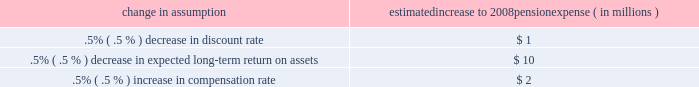Recent accounting pronouncements see note 1 accounting policies in the notes to consolidated financial statements in item 8 of this report for additional information on the following recent accounting pronouncements that are relevant to our business , including a description of each new pronouncement , the required date of adoption , our planned date of adoption , and the expected impact on our consolidated financial statements .
All of the following pronouncements were issued by the fasb unless otherwise noted .
The following were issued in 2007 : 2022 sfas 141 ( r ) , 201cbusiness combinations 201d 2022 sfas 160 , 201caccounting and reporting of noncontrolling interests in consolidated financial statements , an amendment of arb no .
51 201d 2022 in november 2007 , the sec issued staff accounting bulletin no .
109 , 2022 in june 2007 , the aicpa issued statement of position 07-1 , 201cclarification of the scope of the audit and accounting guide 201cinvestment companies 201d and accounting by parent companies and equity method investors for investments in investment companies . 201d the fasb issued a final fsp in february 2008 which indefinitely delays the effective date of aicpa sop 07-1 .
2022 fasb staff position no .
( 201cfsp 201d ) fin 46 ( r ) 7 , 201capplication of fasb interpretation no .
46 ( r ) to investment companies 201d 2022 fsp fin 48-1 , 201cdefinition of settlement in fasb interpretation ( 201cfin 201d ) no .
48 201d 2022 sfas 159 , 201cthe fair value option for financial assets and financial liabilities 2013 including an amendment of fasb statement no .
115 201d the following were issued during 2006 : 2022 sfas 158 , 201cemployers 2019 accounting for defined benefit pension and other postretirement benefit plans 2013 an amendment of fasb statements no .
87 , 88 , 106 and 132 ( r ) 201d ( 201csfas 158 201d ) 2022 sfas 157 , 201cfair value measurements 201d 2022 fin 48 , 201caccounting for uncertainty in income taxes 2013 an interpretation of fasb statement no .
109 201d 2022 fsp fas 13-2 , 201caccounting for a change or projected change in the timing of cash flows relating to income taxes generated by a leveraged lease transaction 201d 2022 sfas 156 , 201caccounting for servicing of financial assets 2013 an amendment of fasb statement no .
140 201d 2022 sfas 155 , 201caccounting for certain hybrid financial instruments 2013 an amendment of fasb statements no .
133 and 140 201d 2022 the emerging issues task force ( 201ceitf 201d ) of the fasb issued eitf issue 06-4 , 201caccounting for deferred compensation and postretirement benefit aspects of endorsement split-dollar life insurance arrangements 201d status of defined benefit pension plan we have a noncontributory , qualified defined benefit pension plan ( 201cplan 201d or 201cpension plan 201d ) covering eligible employees .
Benefits are derived from a cash balance formula based on compensation levels , age and length of service .
Pension contributions are based on an actuarially determined amount necessary to fund total benefits payable to plan participants .
Consistent with our investment strategy , plan assets are currently approximately 60% ( 60 % ) invested in equity investments with most of the remainder invested in fixed income instruments .
Plan fiduciaries determine and review the plan 2019s investment policy .
We calculate the expense associated with the pension plan in accordance with sfas 87 , 201cemployers 2019 accounting for pensions , 201d and we use assumptions and methods that are compatible with the requirements of sfas 87 , including a policy of reflecting trust assets at their fair market value .
On an annual basis , we review the actuarial assumptions related to the pension plan , including the discount rate , the rate of compensation increase and the expected return on plan assets .
Neither the discount rate nor the compensation increase assumptions significantly affects pension expense .
The expected long-term return on assets assumption does significantly affect pension expense .
The expected long-term return on plan assets for determining net periodic pension cost for 2007 was 8.25% ( 8.25 % ) , unchanged from 2006 .
Under current accounting rules , the difference between expected long-term returns and actual returns is accumulated and amortized to pension expense over future periods .
Each one percentage point difference in actual return compared with our expected return causes expense in subsequent years to change by up to $ 4 million as the impact is amortized into results of operations .
The table below reflects the estimated effects on pension expense of certain changes in assumptions , using 2008 estimated expense as a baseline .
Change in assumption estimated increase to 2008 pension expense ( in millions ) .
We currently estimate a pretax pension benefit of $ 26 million in 2008 compared with a pretax benefit of $ 30 million in .
Does a .5% ( .5 % ) decrease in expected long-term return on assets have a greater effect on pension expense than a .5% ( .5 % ) increase in compensation rate? 
Computations: (10 > 2)
Answer: yes. 